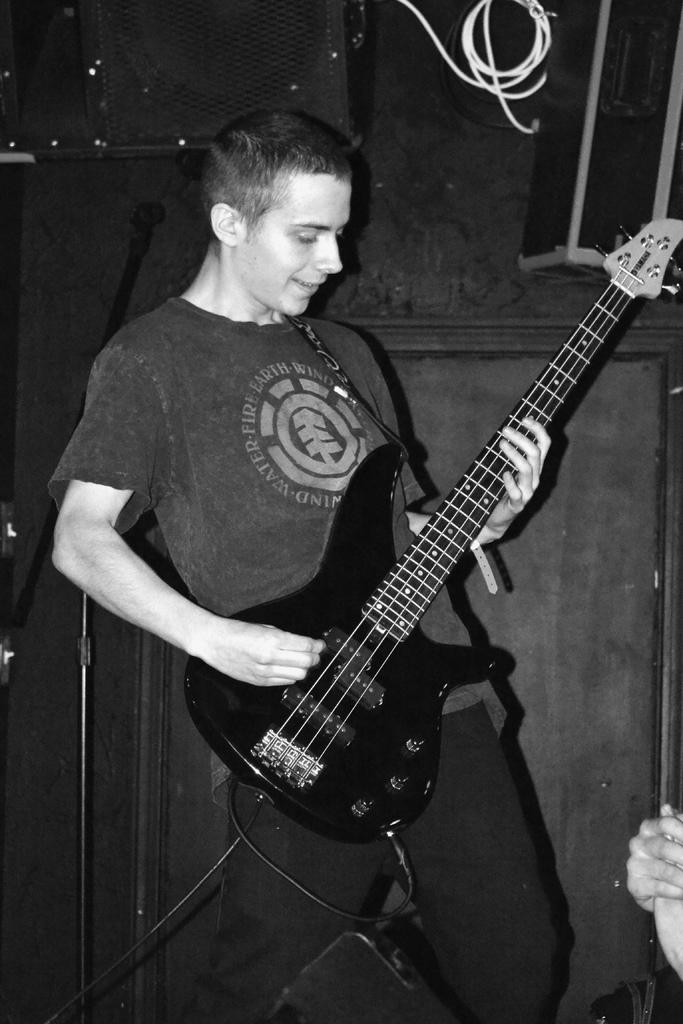What is the man in the image doing? The man is playing a guitar in the image. What is the color scheme of the image? The image is black and white. What type of wound can be seen on the man's arm in the image? There is no wound visible on the man's arm in the image, as it is a black and white photograph and the man is playing a guitar. 